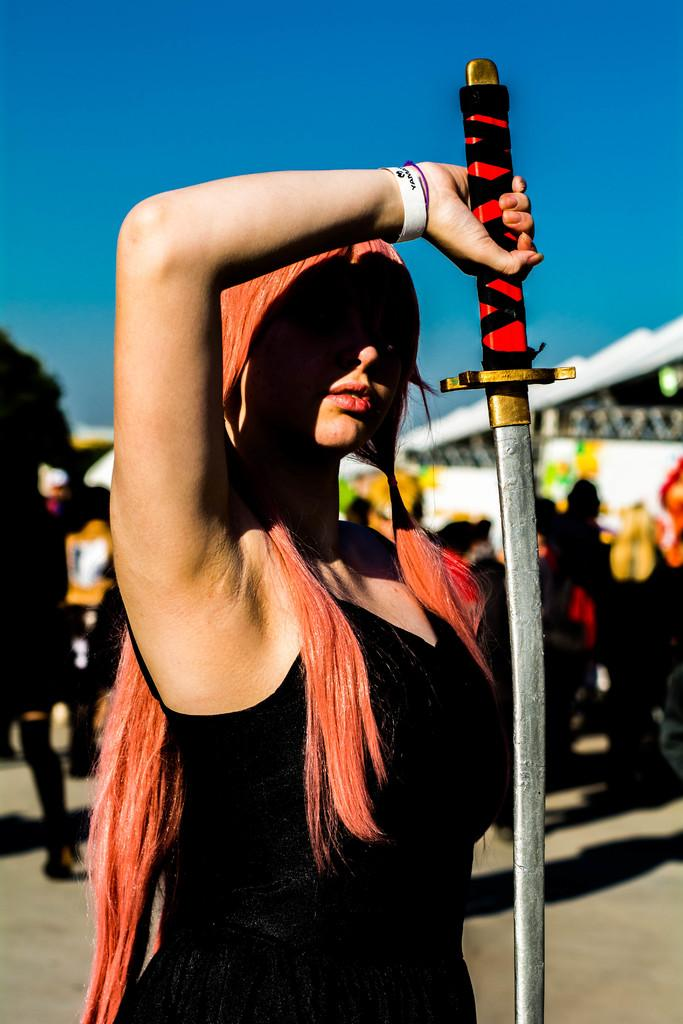Who is the main subject in the image? There is a woman in the image. What is the woman wearing? The woman is wearing a black dress. What object is the woman holding in her hand? The woman is holding a sword in her hand. Can you describe the people behind the woman? There are other people behind the woman, but their specific appearance or actions are not mentioned in the provided facts. What date is circled on the calendar in the image? There is no calendar present in the image, so it is not possible to answer that question. 